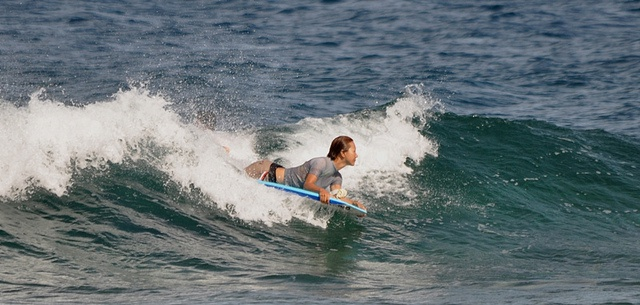Describe the objects in this image and their specific colors. I can see people in blue, gray, darkgray, and tan tones and surfboard in blue, gray, and lightblue tones in this image. 